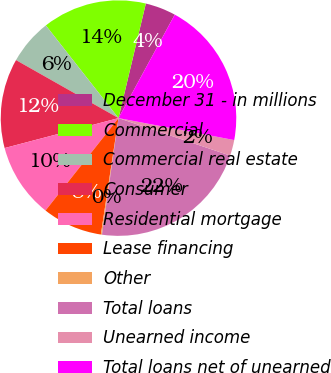Convert chart. <chart><loc_0><loc_0><loc_500><loc_500><pie_chart><fcel>December 31 - in millions<fcel>Commercial<fcel>Commercial real estate<fcel>Consumer<fcel>Residential mortgage<fcel>Lease financing<fcel>Other<fcel>Total loans<fcel>Unearned income<fcel>Total loans net of unearned<nl><fcel>4.2%<fcel>14.31%<fcel>6.22%<fcel>12.29%<fcel>10.27%<fcel>8.24%<fcel>0.15%<fcel>22.09%<fcel>2.17%<fcel>20.06%<nl></chart> 